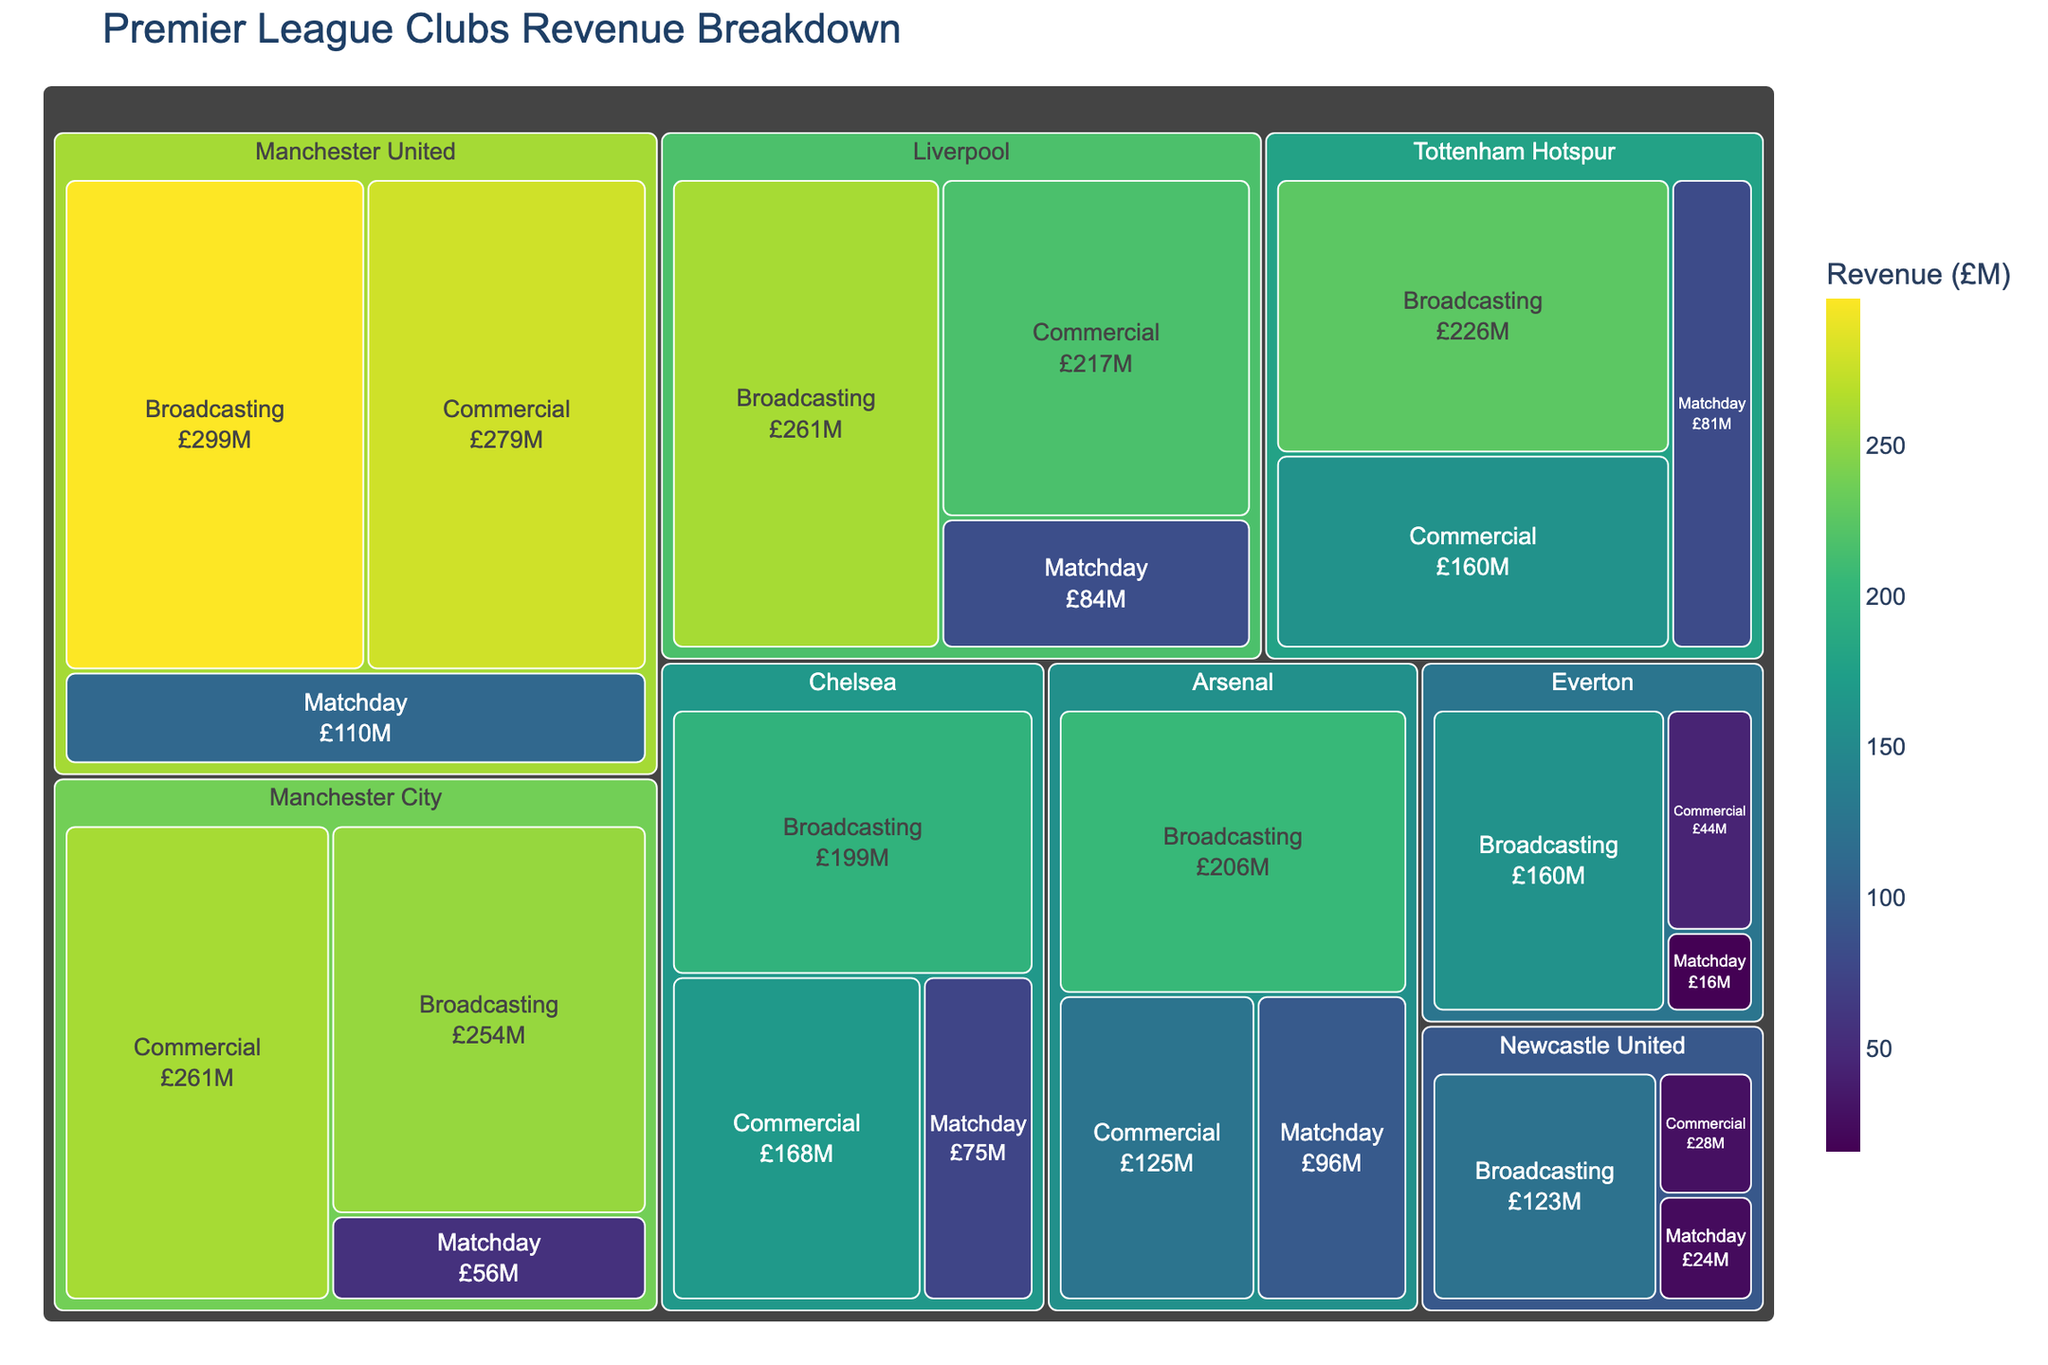Which club has the highest revenue from broadcasting? Identify the club with the largest revenue value under the "Broadcasting" category.
Answer: Manchester United What is the total revenue of Arsenal from all sources? Sum up the revenue figures of Arsenal from Broadcasting, Commercial, and Matchday categories. 206 + 125 + 96 = 427 million.
Answer: 427 million Which club has the lowest revenue from matchday sales? Find the club with the smallest revenue value under the "Matchday" category.
Answer: Everton How does Liverpool's commercial revenue compare to its broadcasting revenue? Compare the revenue figures of Liverpool from Commercial (£217M) and Broadcasting (£261M). Broadcasting revenue is higher in Liverpool.
Answer: Broadcasting is higher What is the average revenue from matchday sales across all clubs? Calculate the average by summing up matchday revenues of all clubs and dividing by the number of clubs (110 + 84 + 96 + 81 + 75 + 56 + 16 + 24 = 542, then 542/8).
Answer: 67.75 million What percentage of Tottenham Hotspur's total revenue comes from commercial sources? First, find Tottenham Hotspur's total revenue (226 + 160 + 81 = 467), then divide the commercial revenue by the total revenue and multiply by 100. (160 / 467) * 100 = 34.26%
Answer: 34.26% Which club has the highest overall revenue? Identify the club with the largest aggregate revenue from all categories (total revenue). Manchester United's total (299 + 279 + 110 = 688) is the largest.
Answer: Manchester United How much more is Manchester United's broadcasting revenue compared to Newcastle United's entire revenue? Subtract Newcastle United's total revenue from Manchester United's broadcasting revenue. Manchester United broadcasting (299) - Newcastle United total (123 + 28 + 24 = 175) = 124.
Answer: 124 million 